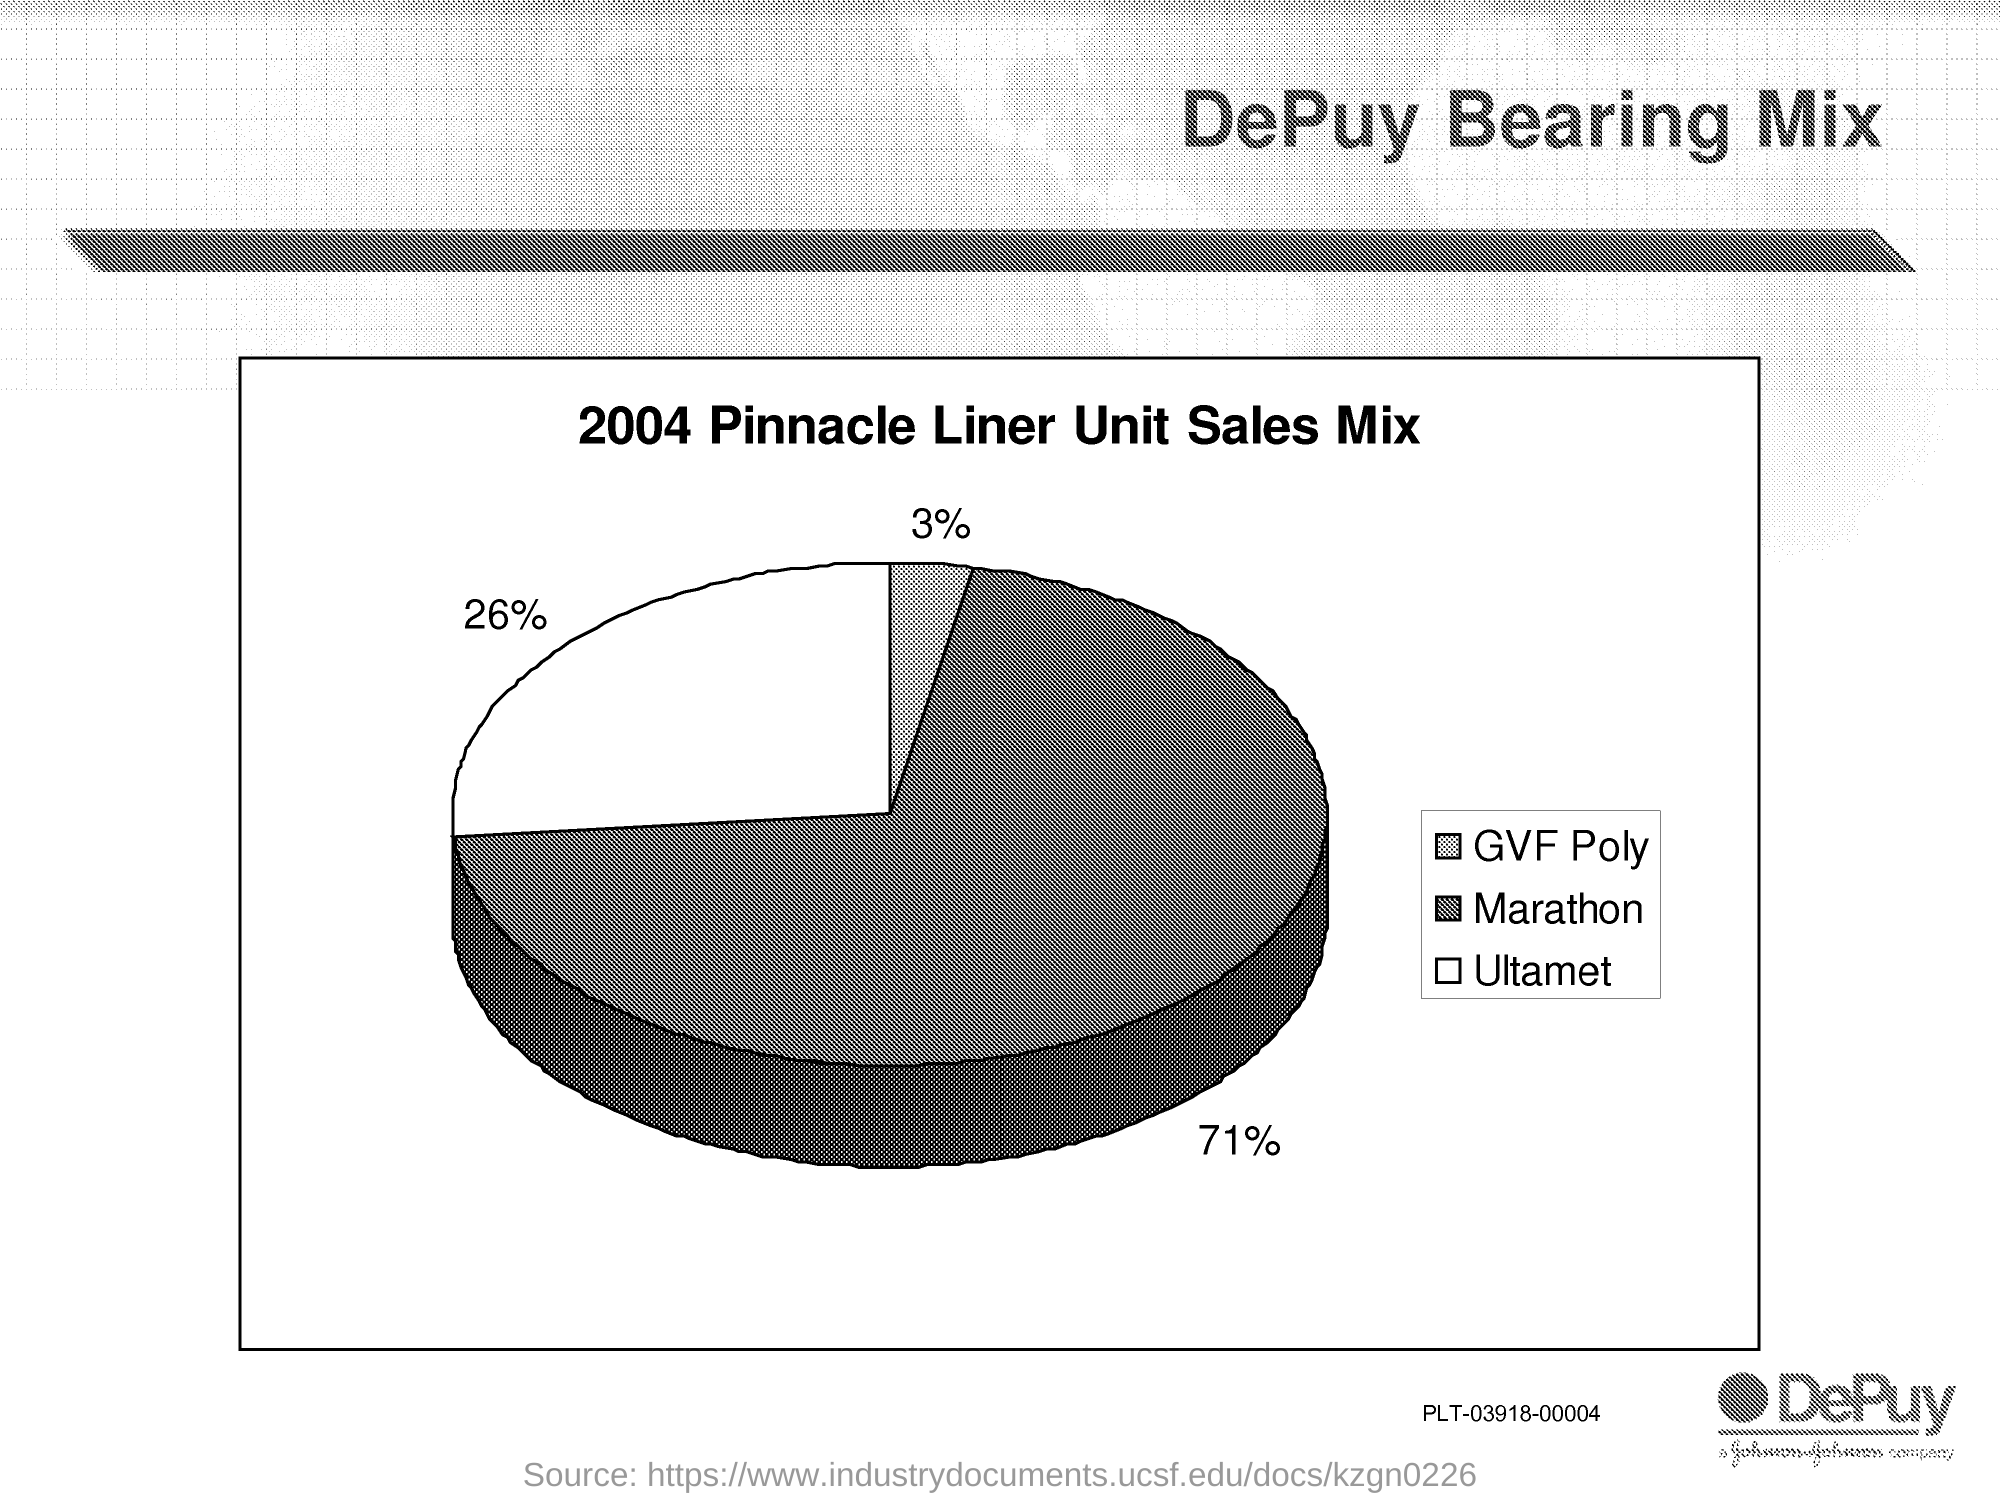What is the percentage of GVF Poly given in the piechart?
Ensure brevity in your answer.  3%. What is the percentage of Marathon given in the piechart?
Provide a succinct answer. 71%. What is the percentage of Ultamet given in the piechart?
Your answer should be very brief. 26%. 